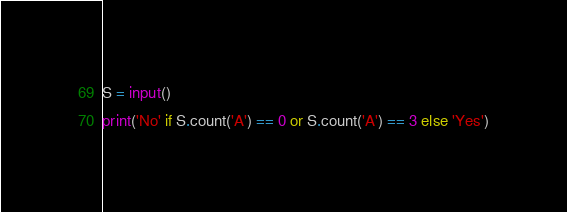<code> <loc_0><loc_0><loc_500><loc_500><_Python_>S = input()
print('No' if S.count('A') == 0 or S.count('A') == 3 else 'Yes')</code> 